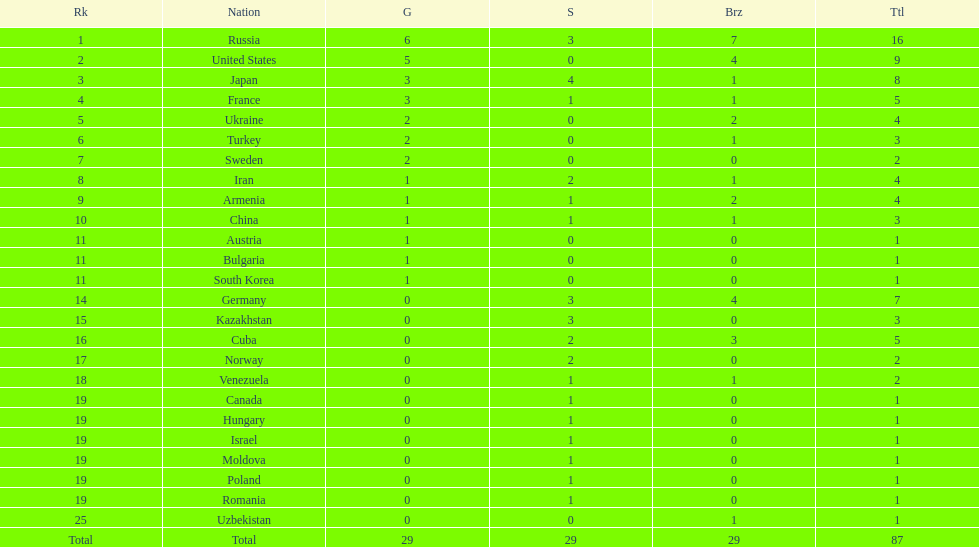Which nation has one gold medal but zero in both silver and bronze? Austria. 